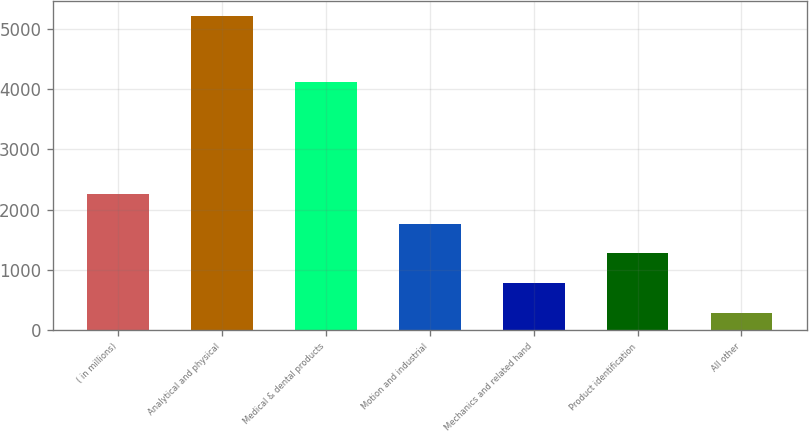Convert chart. <chart><loc_0><loc_0><loc_500><loc_500><bar_chart><fcel>( in millions)<fcel>Analytical and physical<fcel>Medical & dental products<fcel>Motion and industrial<fcel>Mechanics and related hand<fcel>Product identification<fcel>All other<nl><fcel>2258.86<fcel>5206<fcel>4122.9<fcel>1767.67<fcel>785.29<fcel>1276.48<fcel>294.1<nl></chart> 